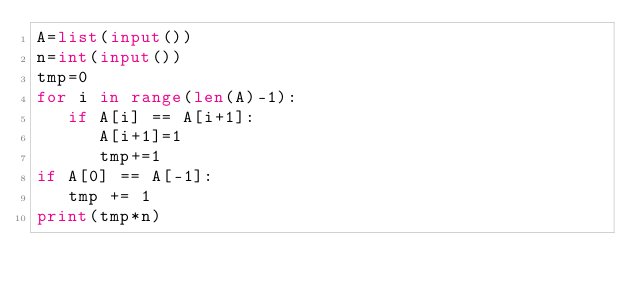Convert code to text. <code><loc_0><loc_0><loc_500><loc_500><_Python_>A=list(input())
n=int(input())
tmp=0
for i in range(len(A)-1):
   if A[i] == A[i+1]:
      A[i+1]=1
      tmp+=1
if A[0] == A[-1]:
   tmp += 1
print(tmp*n)</code> 